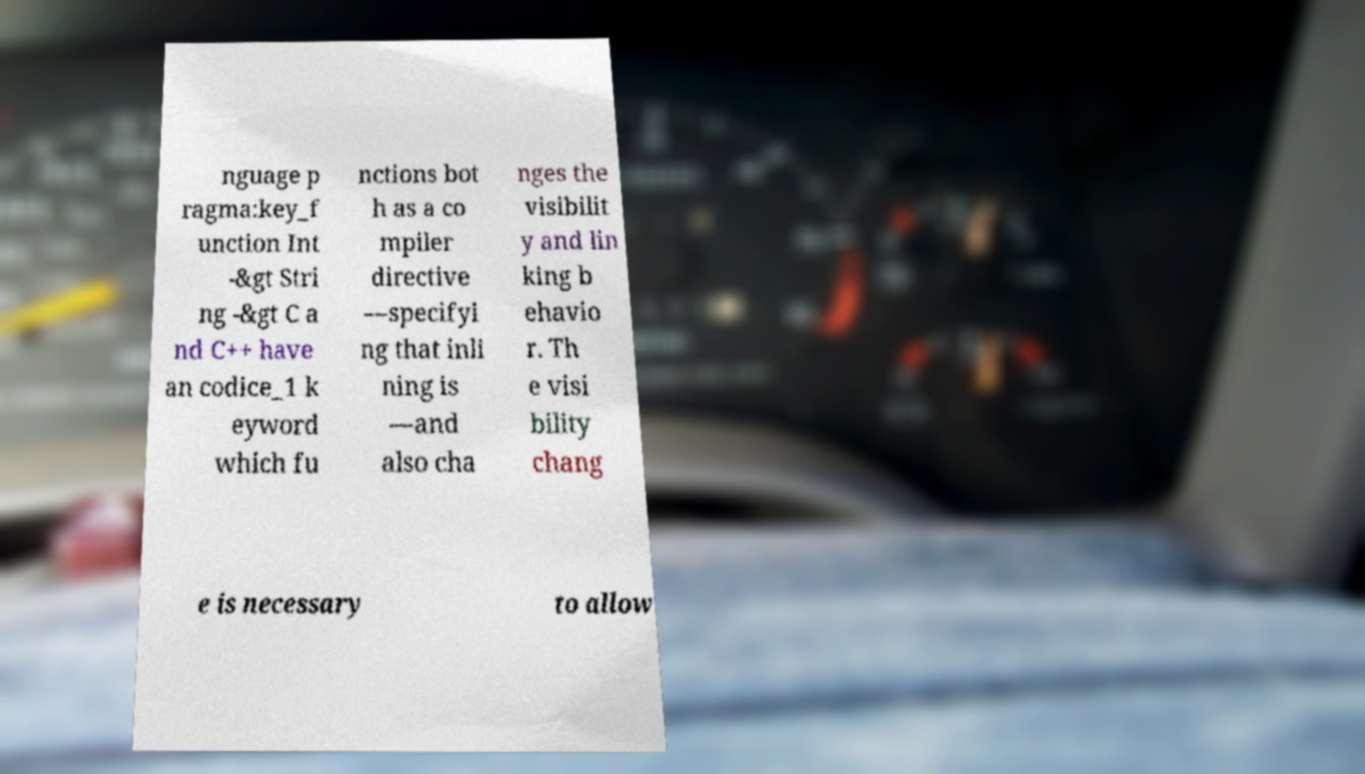Can you accurately transcribe the text from the provided image for me? nguage p ragma:key_f unction Int -&gt Stri ng -&gt C a nd C++ have an codice_1 k eyword which fu nctions bot h as a co mpiler directive —specifyi ng that inli ning is —and also cha nges the visibilit y and lin king b ehavio r. Th e visi bility chang e is necessary to allow 